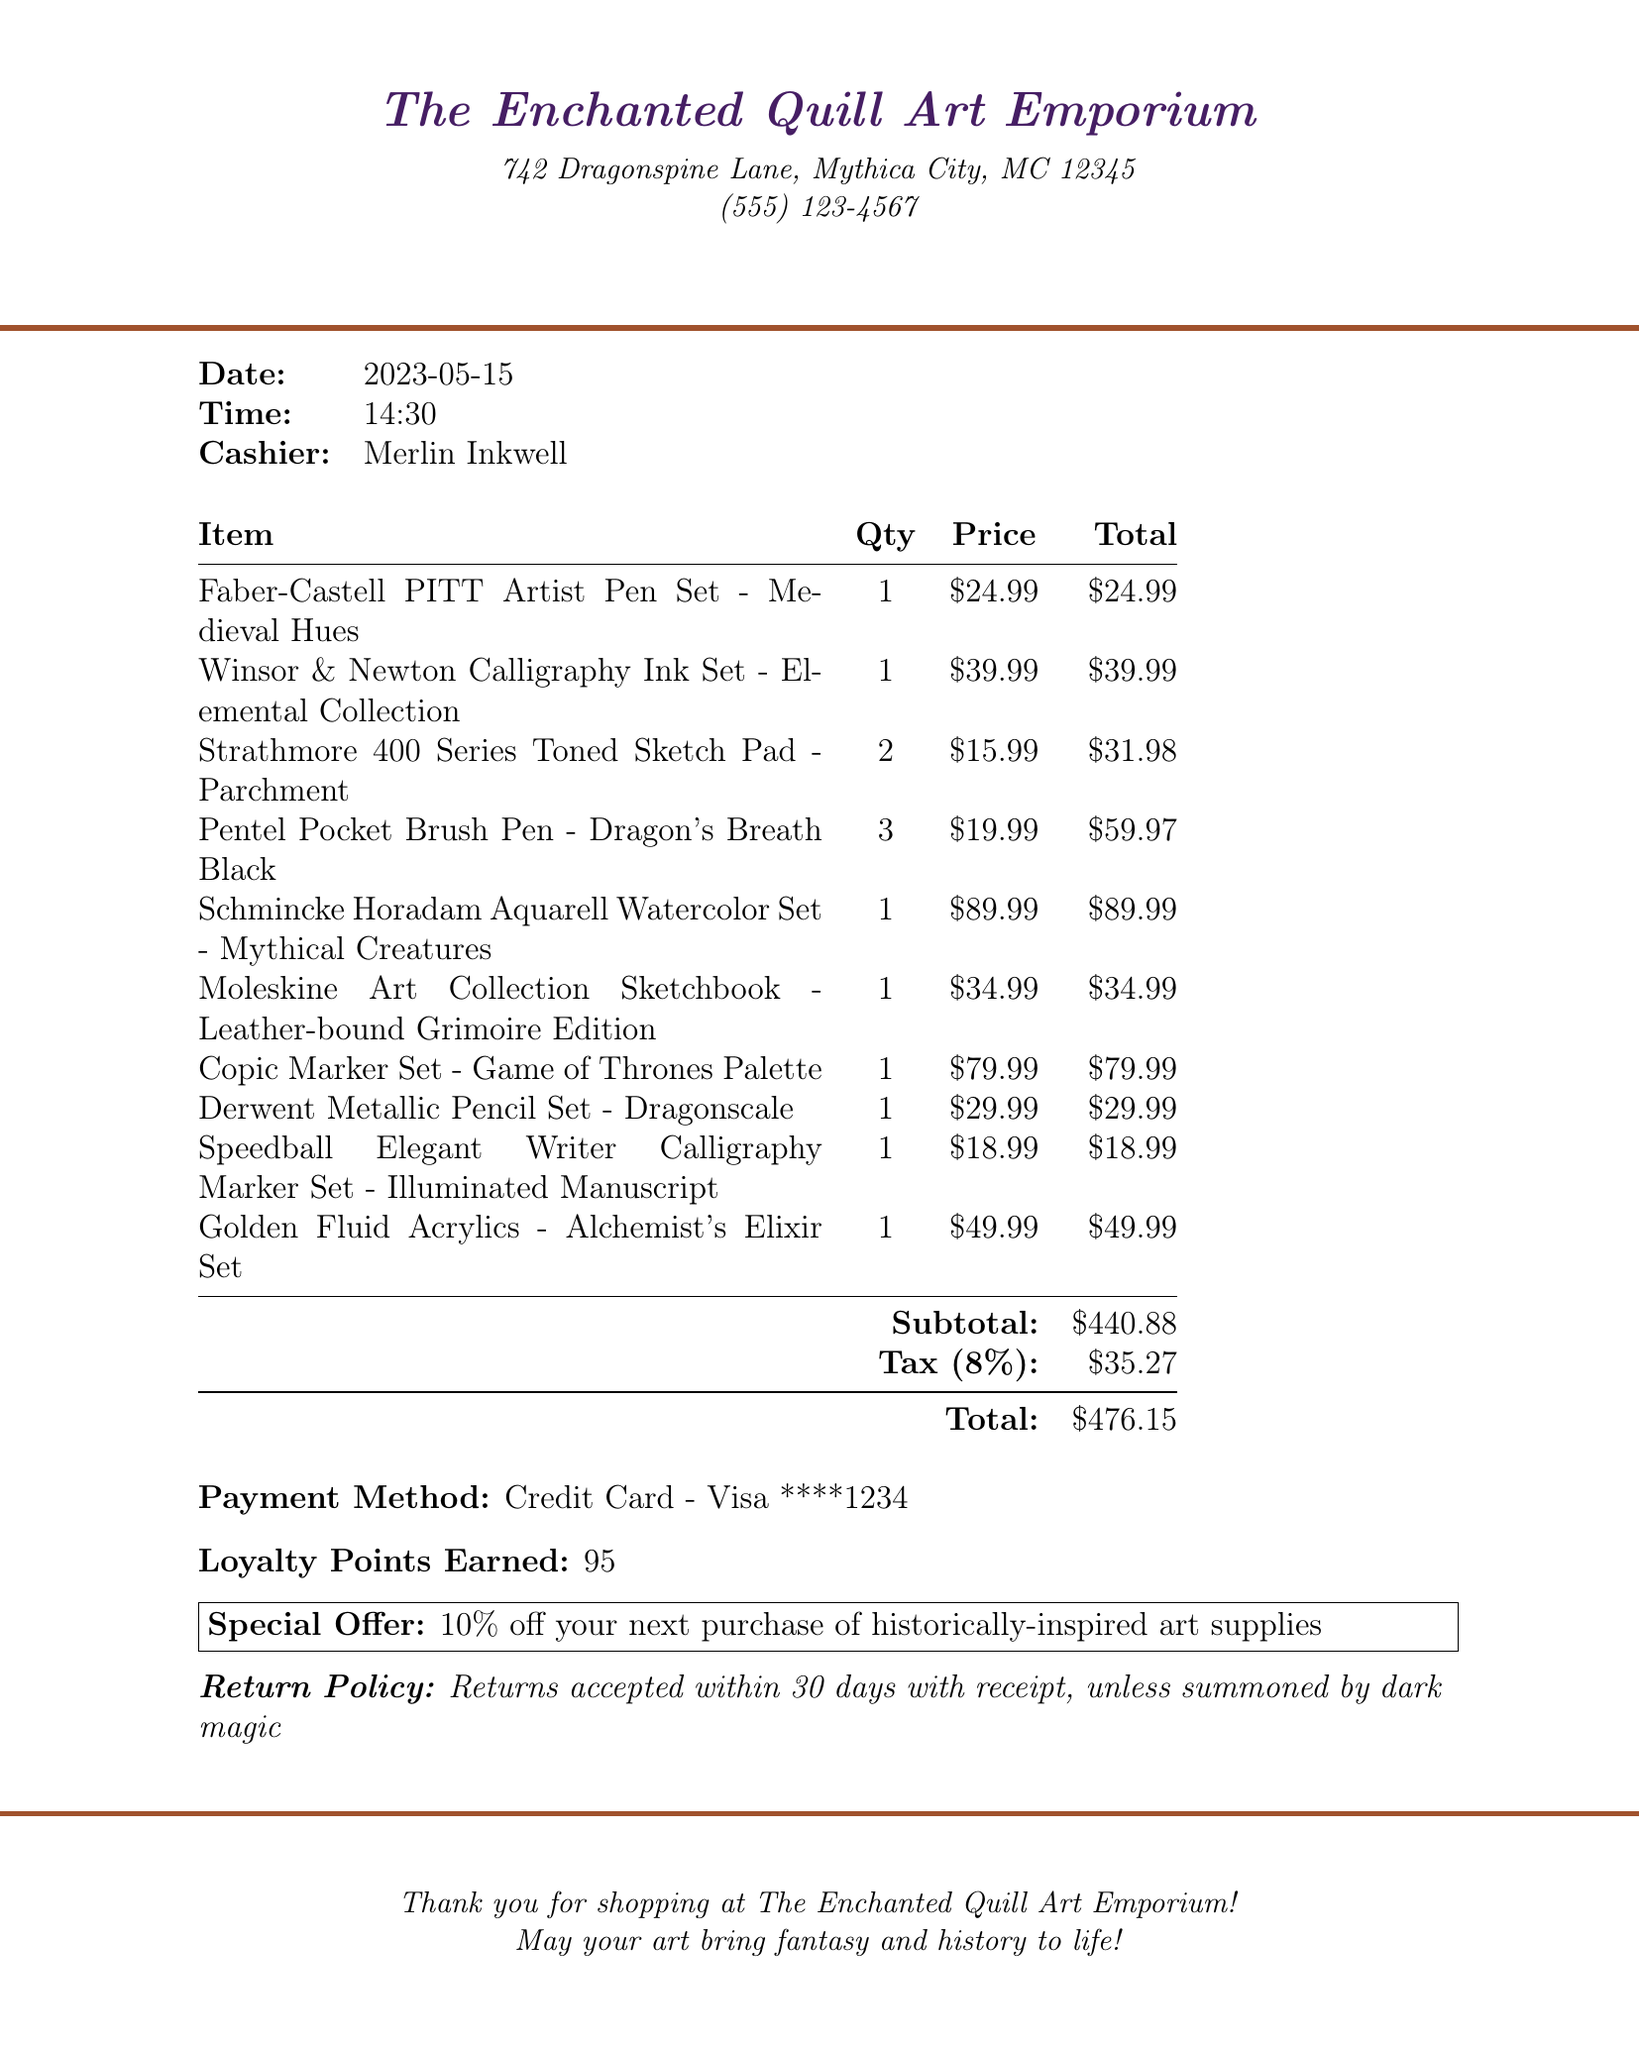what is the name of the store? The store name is clearly stated at the top of the document as 'The Enchanted Quill Art Emporium'.
Answer: The Enchanted Quill Art Emporium what is the address of the store? The address is provided immediately after the store name in the document as '742 Dragonspine Lane, Mythica City, MC 12345'.
Answer: 742 Dragonspine Lane, Mythica City, MC 12345 who was the cashier? The cashier's name is mentioned in the document under the details section as 'Merlin Inkwell'.
Answer: Merlin Inkwell what is the subtotal amount? The subtotal amount is listed in the document under the total section as $440.88.
Answer: $440.88 how many loyalty points were earned? The document specifies that 95 loyalty points were earned from the transaction.
Answer: 95 which item had the highest price? Reviewing the item prices in the document, 'Schmincke Horadam Aquarell Watercolor Set - Mythical Creatures' is listed as the item with the highest price of $89.99.
Answer: Schmincke Horadam Aquarell Watercolor Set - Mythical Creatures what is the special offer provided? The special offer provided in the document states a discount of 10% off on the next purchase of historically-inspired art supplies.
Answer: 10% off your next purchase of historically-inspired art supplies what is the return policy? The return policy is noted towards the end of the document, it states that returns are accepted within 30 days with a receipt, unless summoned by dark magic.
Answer: Returns accepted within 30 days with receipt, unless summoned by dark magic how many items were purchased in total? The document lists a total of 10 different items under the itemized bill section.
Answer: 10 